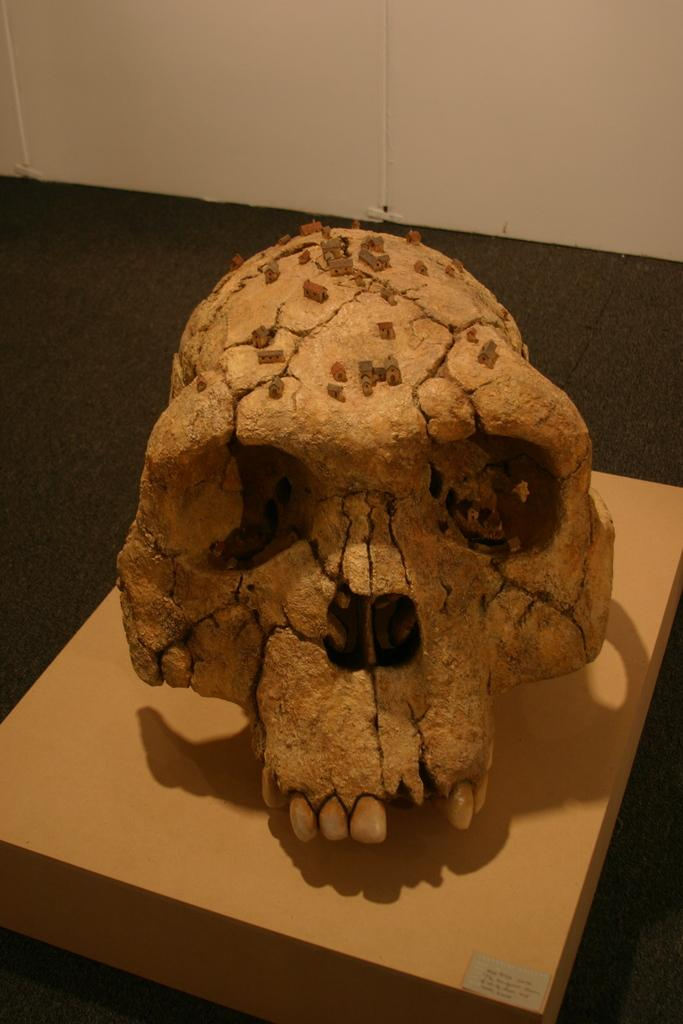What is the main subject of the image? There is a skull in the image. What is the skull resting on? The skull is on wooden material. Where is the wooden material located? The wooden material is on the floor. What can be seen in the background of the image? There is a wall visible at the top of the image. What type of eggnog is being served in the image? There is no eggnog present in the image; it features a skull on wooden material on the floor. What kind of pear is depicted on the wall in the image? There is no pear depicted on the wall in the image; it only shows a wall in the background. 